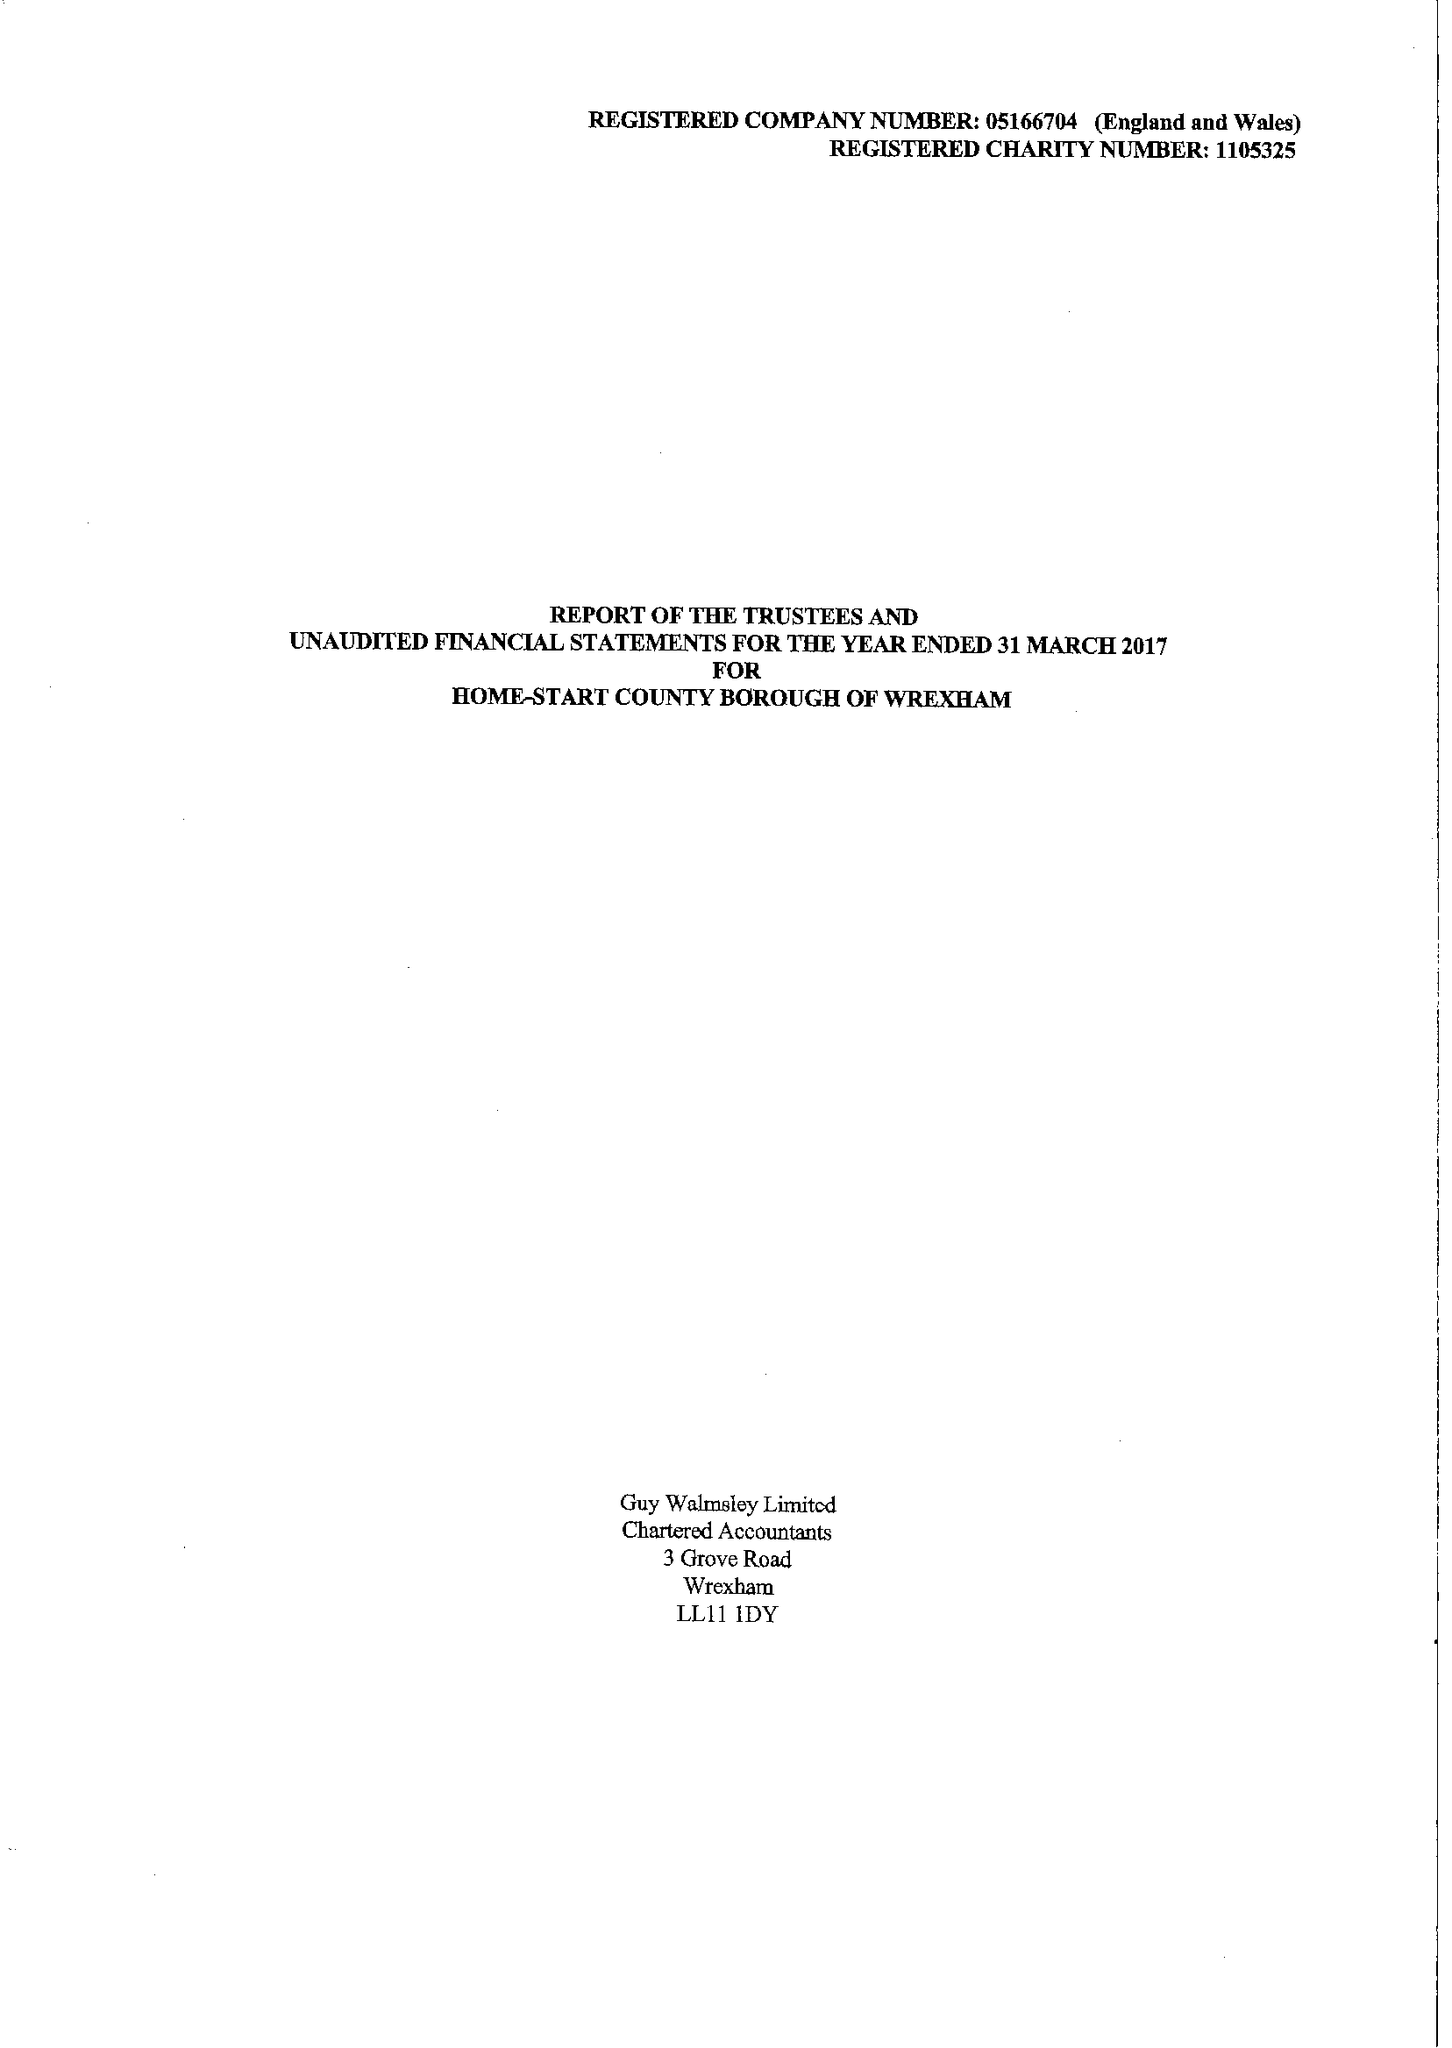What is the value for the income_annually_in_british_pounds?
Answer the question using a single word or phrase. 132831.00 